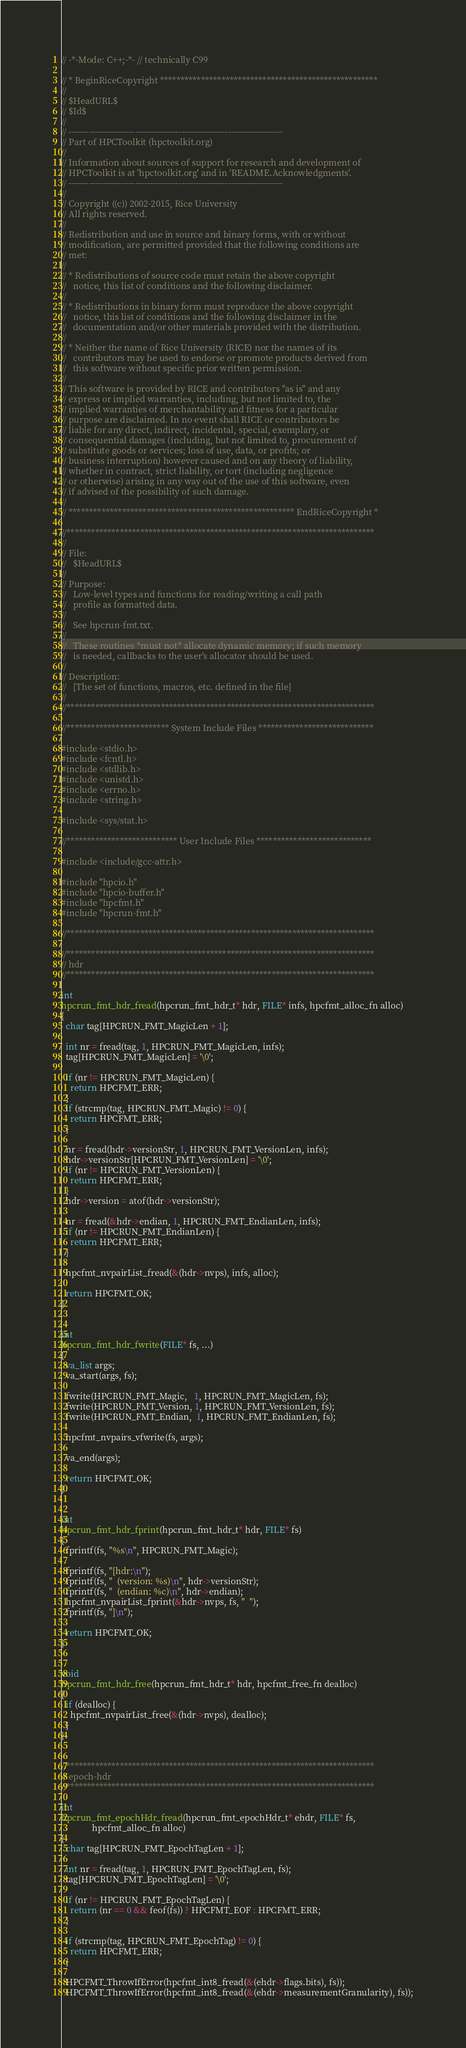Convert code to text. <code><loc_0><loc_0><loc_500><loc_500><_C_>// -*-Mode: C++;-*- // technically C99

// * BeginRiceCopyright *****************************************************
//
// $HeadURL$
// $Id$
//
// --------------------------------------------------------------------------
// Part of HPCToolkit (hpctoolkit.org)
//
// Information about sources of support for research and development of
// HPCToolkit is at 'hpctoolkit.org' and in 'README.Acknowledgments'.
// --------------------------------------------------------------------------
//
// Copyright ((c)) 2002-2015, Rice University
// All rights reserved.
//
// Redistribution and use in source and binary forms, with or without
// modification, are permitted provided that the following conditions are
// met:
//
// * Redistributions of source code must retain the above copyright
//   notice, this list of conditions and the following disclaimer.
//
// * Redistributions in binary form must reproduce the above copyright
//   notice, this list of conditions and the following disclaimer in the
//   documentation and/or other materials provided with the distribution.
//
// * Neither the name of Rice University (RICE) nor the names of its
//   contributors may be used to endorse or promote products derived from
//   this software without specific prior written permission.
//
// This software is provided by RICE and contributors "as is" and any
// express or implied warranties, including, but not limited to, the
// implied warranties of merchantability and fitness for a particular
// purpose are disclaimed. In no event shall RICE or contributors be
// liable for any direct, indirect, incidental, special, exemplary, or
// consequential damages (including, but not limited to, procurement of
// substitute goods or services; loss of use, data, or profits; or
// business interruption) however caused and on any theory of liability,
// whether in contract, strict liability, or tort (including negligence
// or otherwise) arising in any way out of the use of this software, even
// if advised of the possibility of such damage.
//
// ******************************************************* EndRiceCopyright *

//***************************************************************************
//
// File:
//   $HeadURL$
//
// Purpose:
//   Low-level types and functions for reading/writing a call path
//   profile as formatted data.
//
//   See hpcrun-fmt.txt.
//
//   These routines *must not* allocate dynamic memory; if such memory
//   is needed, callbacks to the user's allocator should be used.
//
// Description:
//   [The set of functions, macros, etc. defined in the file]
//
//***************************************************************************

//************************* System Include Files ****************************

#include <stdio.h>
#include <fcntl.h>
#include <stdlib.h>
#include <unistd.h>
#include <errno.h>
#include <string.h>

#include <sys/stat.h>

//*************************** User Include Files ****************************

#include <include/gcc-attr.h>

#include "hpcio.h"
#include "hpcio-buffer.h"
#include "hpcfmt.h"
#include "hpcrun-fmt.h"

//***************************************************************************

//***************************************************************************
// hdr
//***************************************************************************

int
hpcrun_fmt_hdr_fread(hpcrun_fmt_hdr_t* hdr, FILE* infs, hpcfmt_alloc_fn alloc)
{
  char tag[HPCRUN_FMT_MagicLen + 1];

  int nr = fread(tag, 1, HPCRUN_FMT_MagicLen, infs);
  tag[HPCRUN_FMT_MagicLen] = '\0';

  if (nr != HPCRUN_FMT_MagicLen) {
    return HPCFMT_ERR;
  }
  if (strcmp(tag, HPCRUN_FMT_Magic) != 0) {
    return HPCFMT_ERR;
  }

  nr = fread(hdr->versionStr, 1, HPCRUN_FMT_VersionLen, infs);
  hdr->versionStr[HPCRUN_FMT_VersionLen] = '\0';
  if (nr != HPCRUN_FMT_VersionLen) {
    return HPCFMT_ERR;
  }
  hdr->version = atof(hdr->versionStr);

  nr = fread(&hdr->endian, 1, HPCRUN_FMT_EndianLen, infs);
  if (nr != HPCRUN_FMT_EndianLen) {
    return HPCFMT_ERR;
  }

  hpcfmt_nvpairList_fread(&(hdr->nvps), infs, alloc);

  return HPCFMT_OK;
}


int
hpcrun_fmt_hdr_fwrite(FILE* fs, ...)
{
  va_list args;
  va_start(args, fs);

  fwrite(HPCRUN_FMT_Magic,   1, HPCRUN_FMT_MagicLen, fs);
  fwrite(HPCRUN_FMT_Version, 1, HPCRUN_FMT_VersionLen, fs);
  fwrite(HPCRUN_FMT_Endian,  1, HPCRUN_FMT_EndianLen, fs);

  hpcfmt_nvpairs_vfwrite(fs, args);

  va_end(args);

  return HPCFMT_OK;
}


int
hpcrun_fmt_hdr_fprint(hpcrun_fmt_hdr_t* hdr, FILE* fs)
{
  fprintf(fs, "%s\n", HPCRUN_FMT_Magic);

  fprintf(fs, "[hdr:\n");
  fprintf(fs, "  (version: %s)\n", hdr->versionStr);
  fprintf(fs, "  (endian: %c)\n", hdr->endian);
  hpcfmt_nvpairList_fprint(&hdr->nvps, fs, "  ");
  fprintf(fs, "]\n");

  return HPCFMT_OK;
}


void
hpcrun_fmt_hdr_free(hpcrun_fmt_hdr_t* hdr, hpcfmt_free_fn dealloc)
{
  if (dealloc) {
    hpcfmt_nvpairList_free(&(hdr->nvps), dealloc);
  }
}


//***************************************************************************
// epoch-hdr
//***************************************************************************

int
hpcrun_fmt_epochHdr_fread(hpcrun_fmt_epochHdr_t* ehdr, FILE* fs,
			  hpcfmt_alloc_fn alloc)
{
  char tag[HPCRUN_FMT_EpochTagLen + 1];

  int nr = fread(tag, 1, HPCRUN_FMT_EpochTagLen, fs);
  tag[HPCRUN_FMT_EpochTagLen] = '\0';
  
  if (nr != HPCRUN_FMT_EpochTagLen) {
    return (nr == 0 && feof(fs)) ? HPCFMT_EOF : HPCFMT_ERR;
  }

  if (strcmp(tag, HPCRUN_FMT_EpochTag) != 0) {
    return HPCFMT_ERR;
  }

  HPCFMT_ThrowIfError(hpcfmt_int8_fread(&(ehdr->flags.bits), fs));
  HPCFMT_ThrowIfError(hpcfmt_int8_fread(&(ehdr->measurementGranularity), fs));</code> 